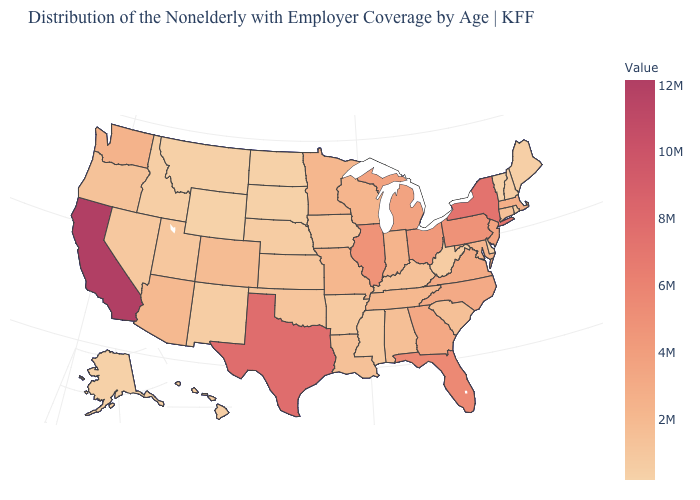Is the legend a continuous bar?
Give a very brief answer. Yes. Among the states that border New Hampshire , does Massachusetts have the highest value?
Write a very short answer. Yes. Which states have the highest value in the USA?
Short answer required. California. Which states hav the highest value in the West?
Write a very short answer. California. 